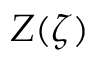<formula> <loc_0><loc_0><loc_500><loc_500>Z ( \zeta )</formula> 